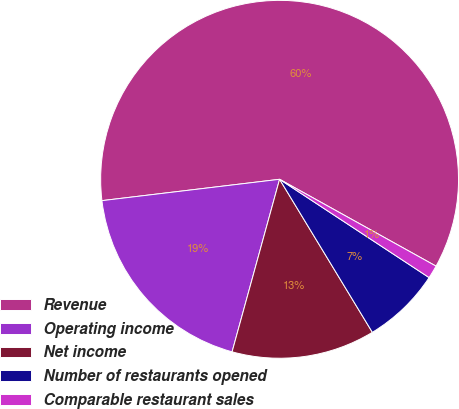Convert chart. <chart><loc_0><loc_0><loc_500><loc_500><pie_chart><fcel>Revenue<fcel>Operating income<fcel>Net income<fcel>Number of restaurants opened<fcel>Comparable restaurant sales<nl><fcel>59.97%<fcel>18.82%<fcel>12.95%<fcel>7.07%<fcel>1.19%<nl></chart> 